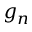Convert formula to latex. <formula><loc_0><loc_0><loc_500><loc_500>g _ { n }</formula> 